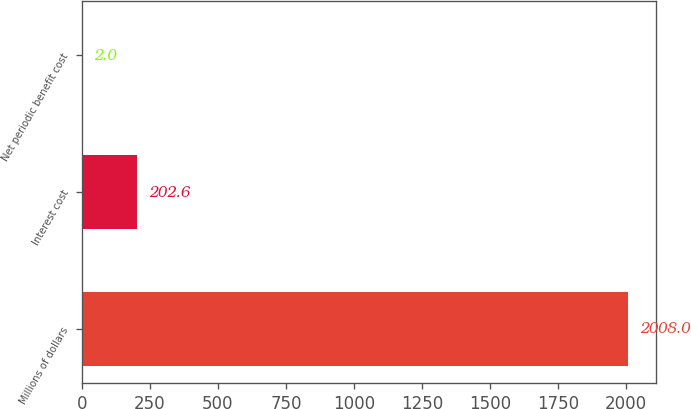Convert chart. <chart><loc_0><loc_0><loc_500><loc_500><bar_chart><fcel>Millions of dollars<fcel>Interest cost<fcel>Net periodic benefit cost<nl><fcel>2008<fcel>202.6<fcel>2<nl></chart> 